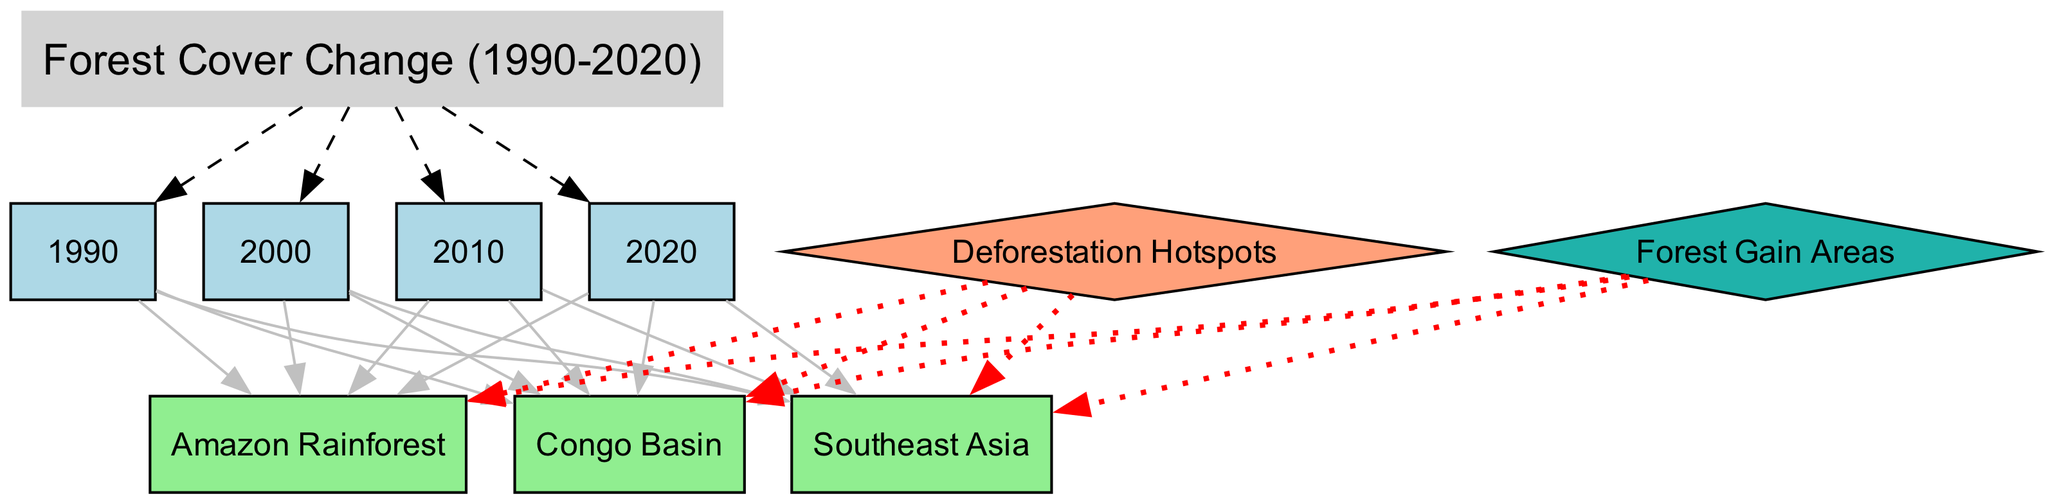What years are represented in the diagram? The nodes labeled as '1990', '2000', '2010', and '2020' represent the years included in the diagram. There are four year nodes in total.
Answer: 1990, 2000, 2010, 2020 Which location is highlighted as a deforestation hotspot? The edges labeled as 'highlight' from the 'Deforestation Hotspots' node show connections to 'Amazon Rainforest', 'Congo Basin', and 'Southeast Asia'. All these locations are tonal hotspots.
Answer: Amazon Rainforest, Congo Basin, Southeast Asia What type of areas are indicated by the 'Forest Gain Areas' node? The edges connecting the 'Forest Gain Areas' node to 'Amazon Rainforest', 'Congo Basin', and 'Southeast Asia' imply that these areas experienced some forest regrowth or gain despite deforestation activities.
Answer: Regrowth areas How many time intervals are observed in the diagram? The diagram contains nodes for four specific years: 1990, 2000, 2010, and 2020, showing the progression of forest cover over time.
Answer: Four Which regions show deforestation status in 2000? The edges from the '2000' node leading to 'Amazon Rainforest', 'Congo Basin', and 'Southeast Asia', indicate that these regions were mentioned with status information.
Answer: Amazon Rainforest, Congo Basin, Southeast Asia Which region is associated with the most recent data point? The '2020' node has edges leading to the 'Amazon Rainforest', 'Congo Basin', and 'Southeast Asia', indicating that all three are relevant to the latest data regarding forest cover.
Answer: Amazon Rainforest, Congo Basin, Southeast Asia Is there a relationship between deforestation hotspots and forest gain areas in the diagram? The edges connecting both 'Deforestation Hotspots' and 'Forest Gain Areas' to the same regions imply that different processes are occurring simultaneously in Amazon Rainforest, Congo Basin, and Southeast Asia.
Answer: Yes What visual style distinguishes the 'hotspot legend' from the 'gain legend'? The 'Deforestation Hotspots' node is represented by a diamond shape with a lightsalmon color, while the 'Forest Gain Areas' node is also a diamond but with lightseagreen color, indicating the type of area visually.
Answer: Color and shape differences What does the dashed line represent in the edges? The edges labeled as 'changes_from' are characterized by dashed lines, indicating a flow or change in forest cover between the years and relevant locations depicted.
Answer: Flow of changes 